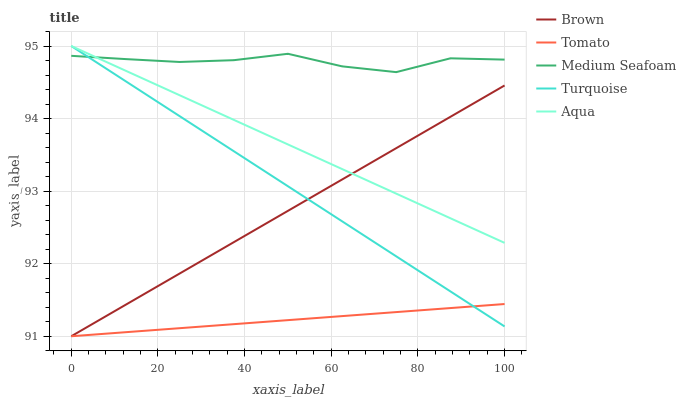Does Tomato have the minimum area under the curve?
Answer yes or no. Yes. Does Medium Seafoam have the maximum area under the curve?
Answer yes or no. Yes. Does Brown have the minimum area under the curve?
Answer yes or no. No. Does Brown have the maximum area under the curve?
Answer yes or no. No. Is Tomato the smoothest?
Answer yes or no. Yes. Is Medium Seafoam the roughest?
Answer yes or no. Yes. Is Turquoise the smoothest?
Answer yes or no. No. Is Turquoise the roughest?
Answer yes or no. No. Does Tomato have the lowest value?
Answer yes or no. Yes. Does Turquoise have the lowest value?
Answer yes or no. No. Does Aqua have the highest value?
Answer yes or no. Yes. Does Brown have the highest value?
Answer yes or no. No. Is Tomato less than Aqua?
Answer yes or no. Yes. Is Aqua greater than Tomato?
Answer yes or no. Yes. Does Tomato intersect Turquoise?
Answer yes or no. Yes. Is Tomato less than Turquoise?
Answer yes or no. No. Is Tomato greater than Turquoise?
Answer yes or no. No. Does Tomato intersect Aqua?
Answer yes or no. No. 